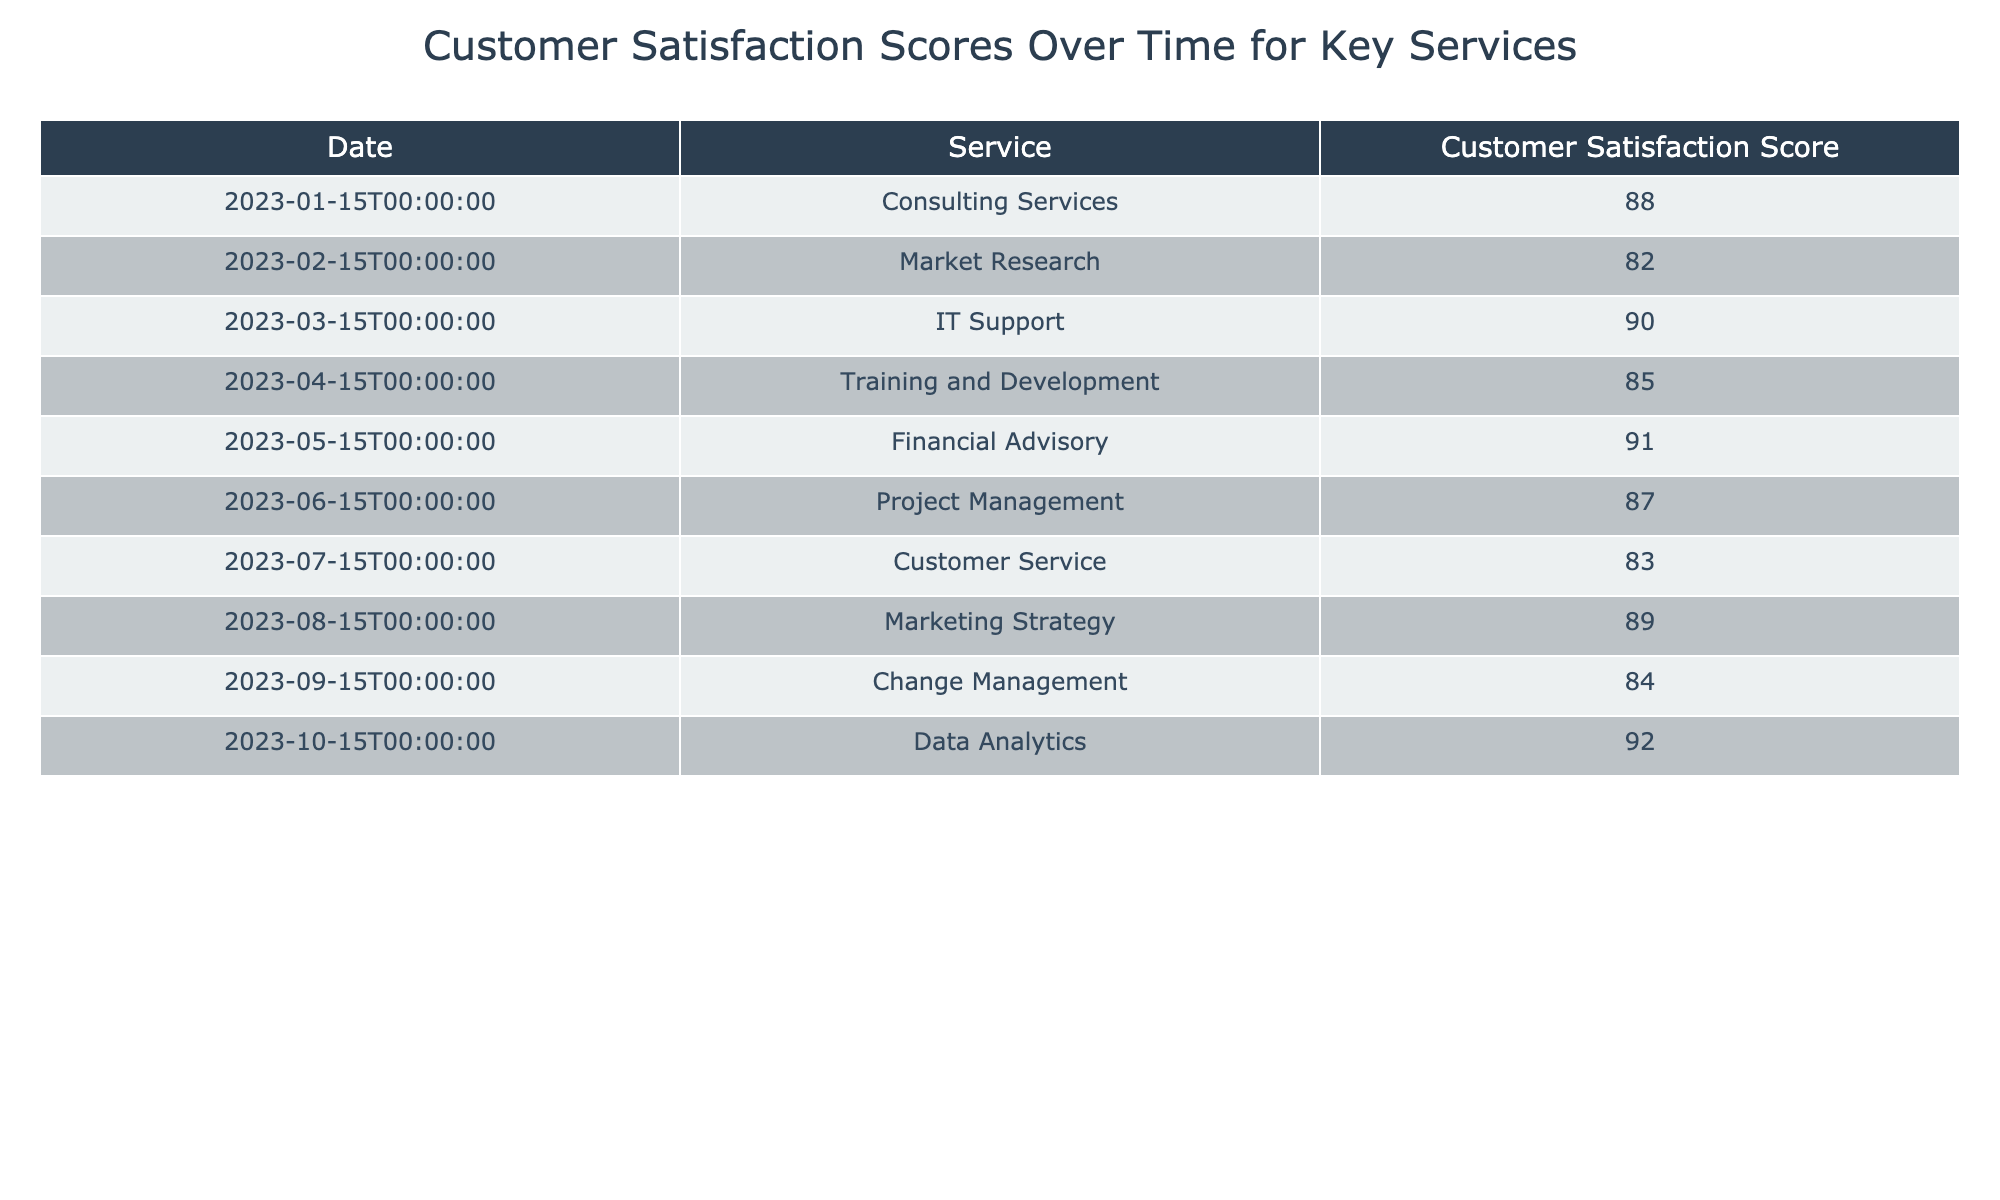What is the customer satisfaction score for IT Support? The table lists the customer satisfaction score specifically for IT Support under the Service column. The score next to IT Support is 90.
Answer: 90 Which service had the highest customer satisfaction score? By examining the scores in the table, Financial Advisory has the highest score listed at 91.
Answer: Financial Advisory What is the average customer satisfaction score for all services? To find the average, we sum all the scores: 88 + 82 + 90 + 85 + 91 + 87 + 83 + 89 + 84 + 92 =  886. There are 10 services, so we divide 886 by 10, which equals 88.6.
Answer: 88.6 Did customer satisfaction for Training and Development exceed 84? The score for Training and Development is 85, which is greater than 84. Thus, the statement is true.
Answer: Yes What is the difference in customer satisfaction scores between Market Research and Data Analytics? For Market Research, the score is 82 and for Data Analytics, it is 92. The difference is calculated as 92 - 82 = 10.
Answer: 10 Which service's customer satisfaction score is closest to the average score calculated? The average score is 88.6. The scores closest to this value are Consulting Services (88) and Training and Development (85). The closest is Consulting Services with an absolute difference of 0.6.
Answer: Consulting Services Is there any service that has a score below 85? Referring to the table, only Market Research (82) and Customer Service (83) have scores below 85. Thus, there are services under 85.
Answer: Yes Which services had scores above 85? The services with scores above 85 include IT Support (90), Financial Advisory (91), Project Management (87), Marketing Strategy (89), and Data Analytics (92). There are five such services.
Answer: Five services 